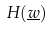Convert formula to latex. <formula><loc_0><loc_0><loc_500><loc_500>H ( \underline { w } )</formula> 